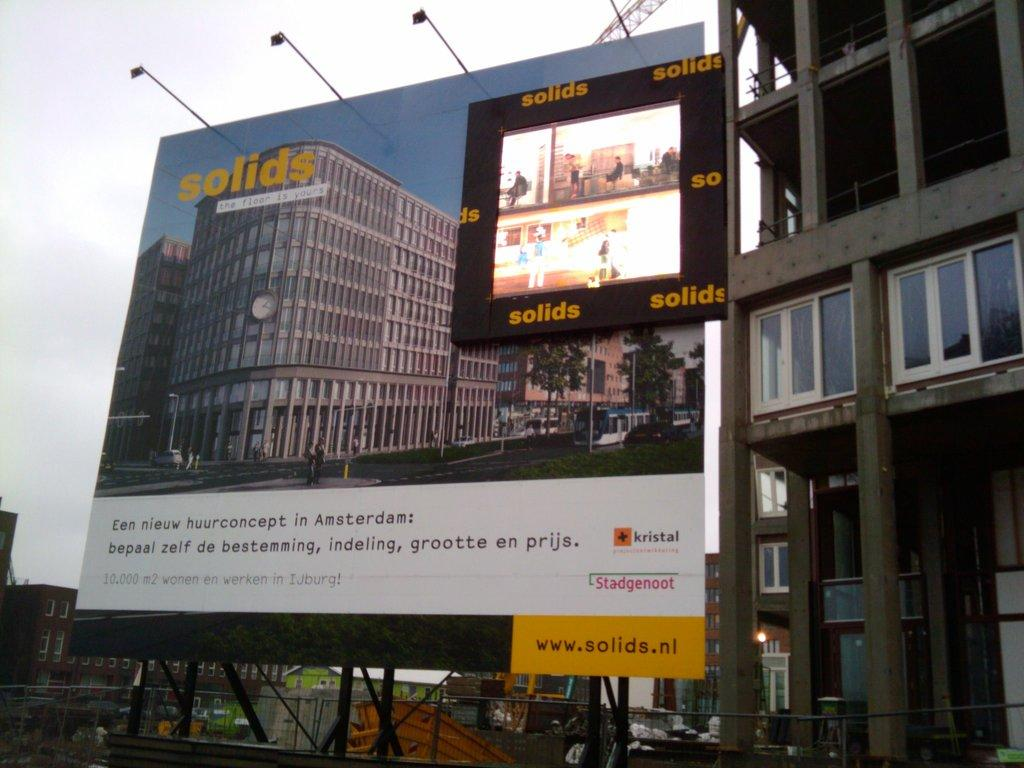<image>
Create a compact narrative representing the image presented. A billboard which has the word solids written on it in orange. 